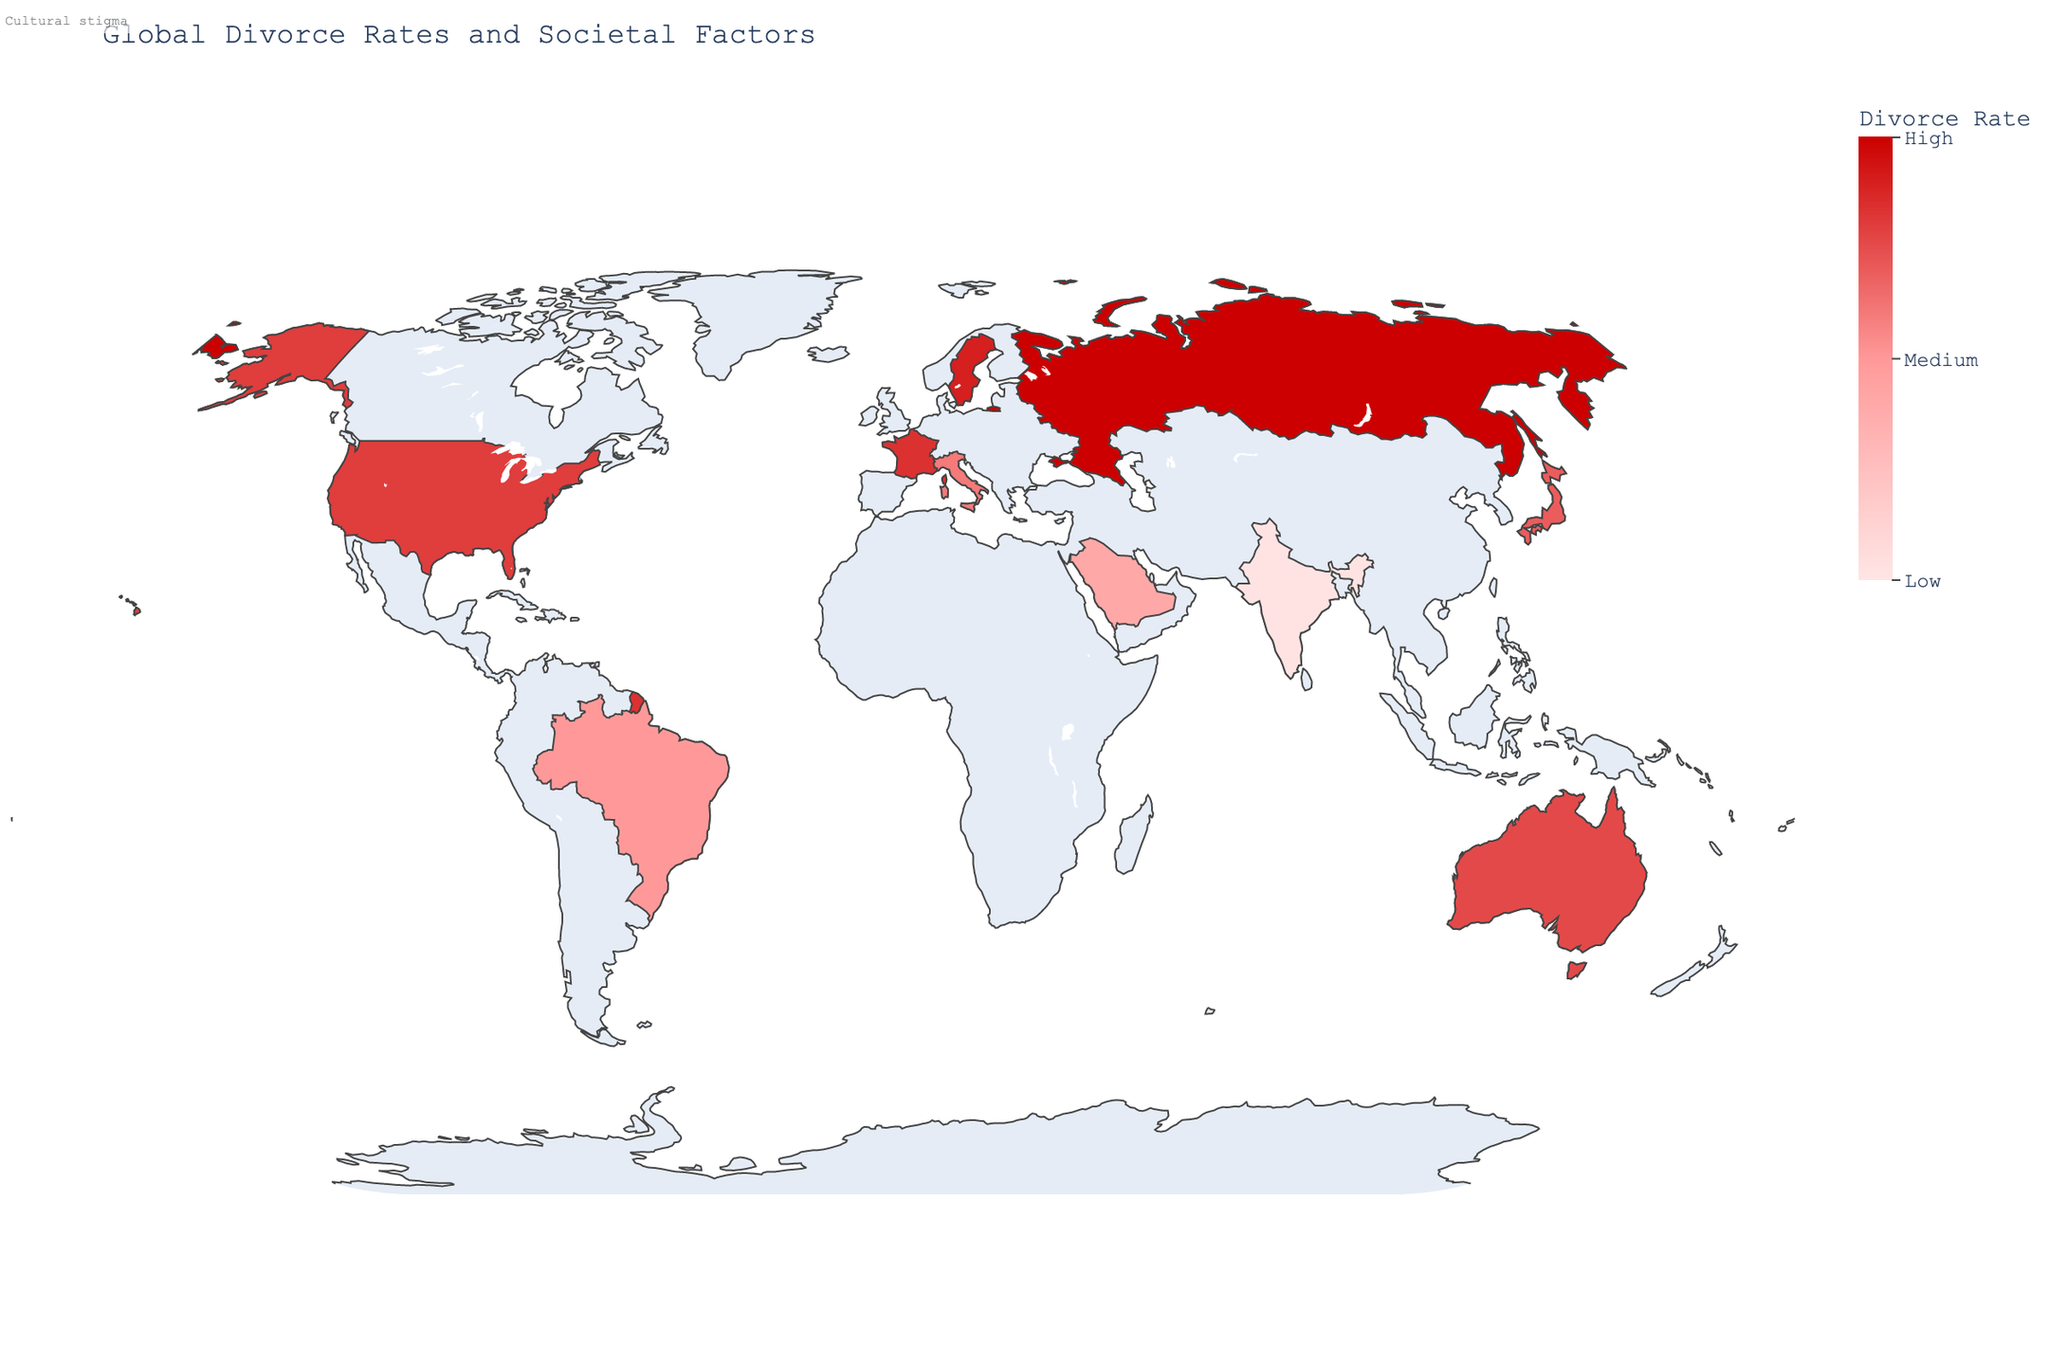Which country has the highest divorce rate? By looking at the color intensity on the map and the numerical annotations, the country with the highest value will correspond to the deepest red color. Russia has the highest divorce rate at 50.
Answer: Russia Which country has the lowest divorce rate? By examining the color scale, the lightest red color or the value closest to zero will correspond to the lowest divorce rate. India has the lowest divorce rate at 1.
Answer: India What societal factor is associated with the divorce rate in Sweden? Hover over Sweden on the map to see the textual annotation. The societal factor is indicated as "Gender equality."
Answer: Gender equality What is the range of divorce rates shown on the map? The color bar indicates the range from 0 to 50, representing the minimum and maximum values of divorce rates among the countries on the map.
Answer: 0 to 50 Which countries have a divorce rate greater than 40? By examining the color intensity and corresponding annotations, the countries with divorce rates greater than 40 are United States (40), Sweden (45), Russia (50), and France (42).
Answer: United States, Sweden, Russia, France What is the average divorce rate of the countries shown? Sum the divorce rates (40 + 30 + 45 + 35 + 25 + 50 + 1 + 38 + 42 + 20) and then divide by the number of countries (10): (326 / 10 = 32.6). The average divorce rate is 32.6.
Answer: 32.6 Which country has an economic instability listed as a societal factor, and what is its divorce rate? Russia is labeled with economic instability as its societal factor in the annotation. Its divorce rate is 50.
Answer: Russia, 50 Is there any country with a divorce rate comparable to that of Saudi Arabia and what is its societal factor? Saudi Arabia has a divorce rate of 20. Brazil, with a divorce rate of 25, is relatively comparable and has "Religious influence" as the societal factor.
Answer: Brazil, Religious influence If we exclude the country with the lowest divorce rate, what would be the new average divorce rate? Exclude India (1) and sum the remaining divorce rates (40 + 30 + 45 + 35 + 25 + 50 + 38 + 42 + 20) which equates to 325. Divide by 9 countries: (325 / 9 = 36.1). The new average is 36.1.
Answer: 36.1 